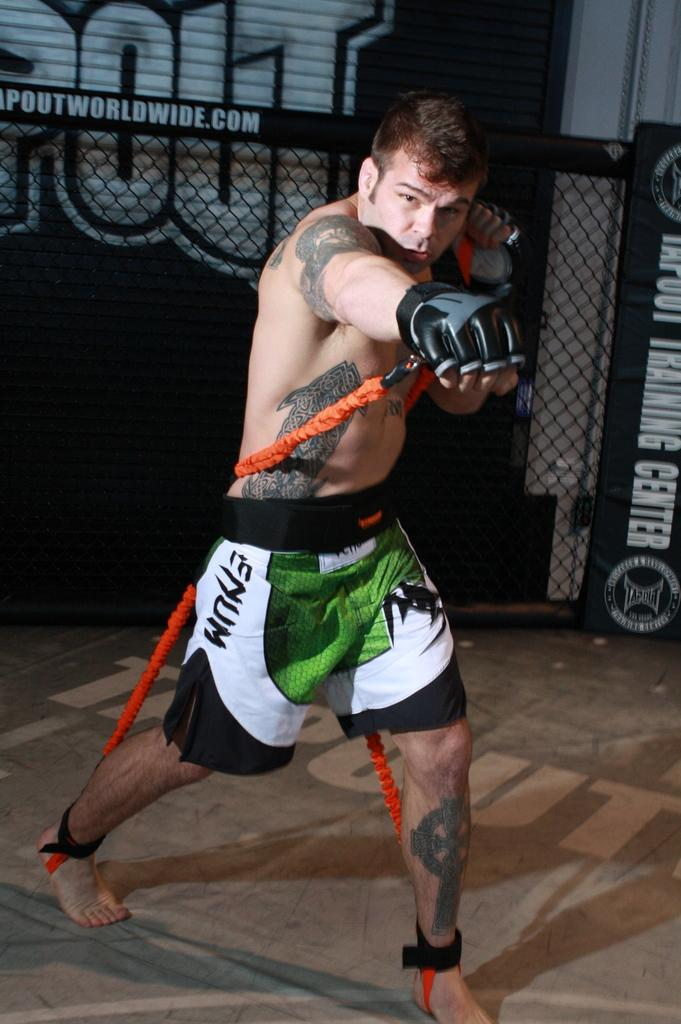<image>
Share a concise interpretation of the image provided. A man working out with a rope wearing Emum shorts. 